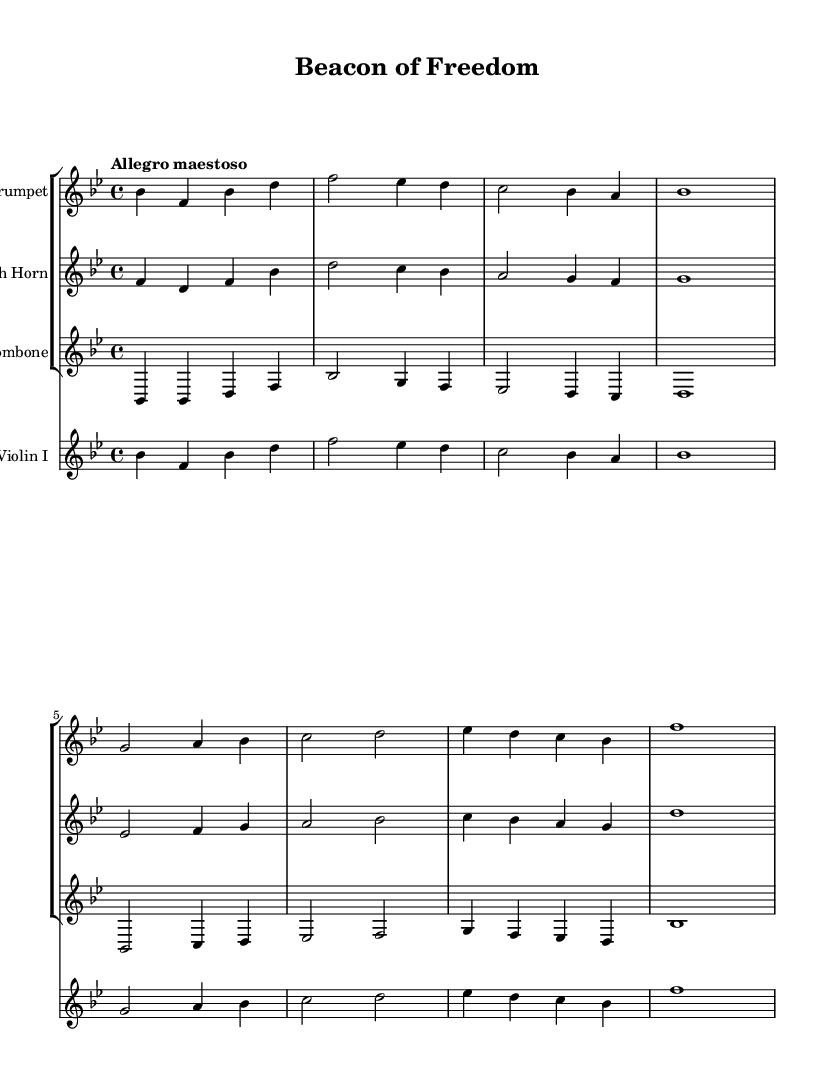What is the title of the music? The title is found in the header section of the sheet music, which lists the composition's name as "Beacon of Freedom."
Answer: Beacon of Freedom What is the key signature of this music? The key signature is indicated at the beginning of the score. It shows two flats (B flat and E flat), corresponding to B flat major.
Answer: B flat major What is the time signature of this music? The time signature appears next to the clef at the beginning of the score, which is 4/4, indicating four beats per measure.
Answer: 4/4 What is the tempo marking for this music? The tempo marking is also found at the beginning and states "Allegro maestoso," which indicates a fast and majestic tempo.
Answer: Allegro maestoso Which instrument has a staff labeled "Violin I"? The staff groupings show one staff specifically labeled "Violin I," indicating that this instrument has its own dedicated part in the score.
Answer: Violin I How many instruments are featured in this score? By counting the instrument staffs in the score, you can see there are four distinct parts: Trumpet, French Horn, Trombone, and Violin I.
Answer: Four Which instrument plays the lowest range throughout the piece? The trombone generally has a lower range than the other instruments listed, such as trumpet and violin, making it the lowest instrument in this score.
Answer: Trombone 